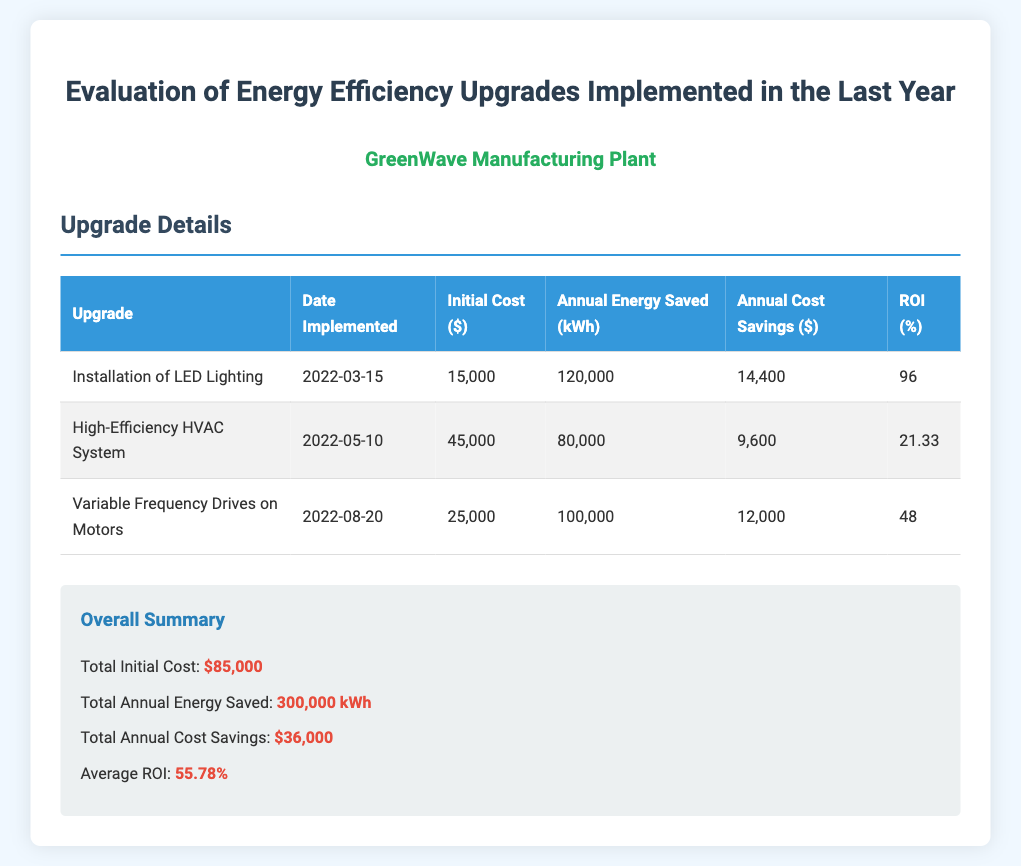What is the total initial cost of upgrades? The total initial cost is provided in the summary section, which adds up all the individual costs of the upgrades.
Answer: $85,000 How much energy is saved annually from LED lighting? The document lists the annual energy saved for each upgrade, with LED lighting specifically saving 120,000 kWh.
Answer: 120,000 kWh What is the implementation date of the High-Efficiency HVAC System? The upgrade detail section specifies the date of each implemented upgrade, with the HVAC system being implemented on 2022-05-10.
Answer: 2022-05-10 What is the ROI for Variable Frequency Drives on Motors? The ROI is noted in the table for each upgrade, and for Variable Frequency Drives, it is 48%.
Answer: 48 What is the average ROI of all upgrades? The average ROI is calculated based on the individual ROIs of all upgrades and stated in the summary section as 55.78%.
Answer: 55.78% How much are the total annual cost savings? The total annual cost savings is summarized in the document, which combines the annual savings from all upgrades.
Answer: $36,000 What type of survey is depicted in the document? The document is specifically about the evaluation of energy efficiency upgrades implemented in a manufacturing plant over the last year.
Answer: Energy Efficiency Upgrades Evaluation Which upgrade had the highest initial cost? The upgrade detail table shows the initial costs for each upgrade, with the High-Efficiency HVAC System costing the most at $45,000.
Answer: High-Efficiency HVAC System How many upgrades were implemented? The table lists the number of different upgrades that were implemented, which totals three.
Answer: Three 